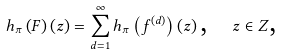Convert formula to latex. <formula><loc_0><loc_0><loc_500><loc_500>h _ { \pi } \left ( F \right ) \left ( z \right ) = \sum _ { d = 1 } ^ { \infty } h _ { \pi } \left ( f ^ { \left ( d \right ) } \right ) \left ( z \right ) \text {, \ \ } z \in Z \text {,}</formula> 